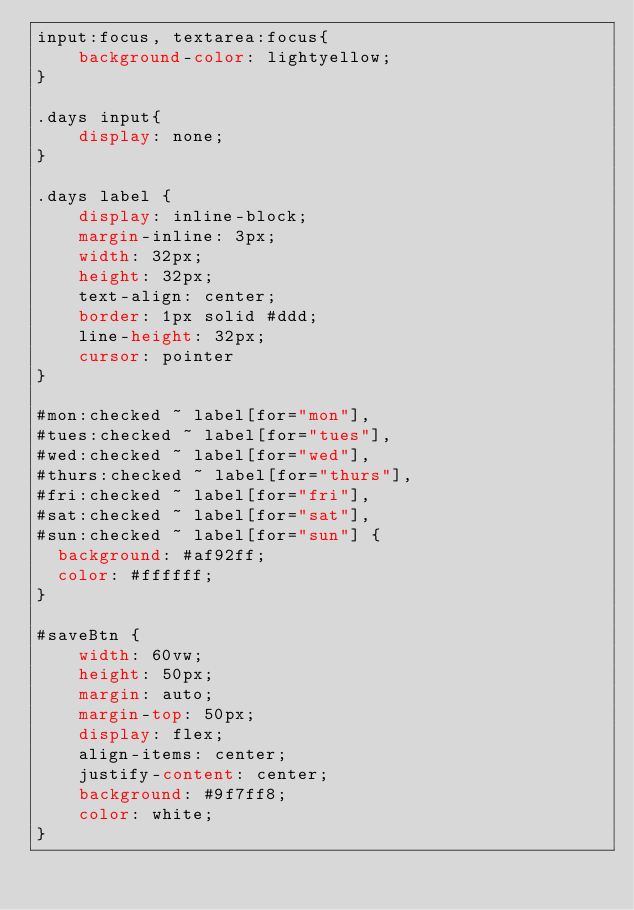<code> <loc_0><loc_0><loc_500><loc_500><_CSS_>input:focus, textarea:focus{
    background-color: lightyellow;
}

.days input{
    display: none;
}
  
.days label {
    display: inline-block;
    margin-inline: 3px;
    width: 32px;
    height: 32px;
    text-align: center;
    border: 1px solid #ddd;
    line-height: 32px;
    cursor: pointer
}

#mon:checked ~ label[for="mon"],
#tues:checked ~ label[for="tues"],
#wed:checked ~ label[for="wed"],
#thurs:checked ~ label[for="thurs"],
#fri:checked ~ label[for="fri"],
#sat:checked ~ label[for="sat"],
#sun:checked ~ label[for="sun"] {
  background: #af92ff;
  color: #ffffff;
}

#saveBtn {
    width: 60vw;
    height: 50px;
    margin: auto;
    margin-top: 50px;
    display: flex;
    align-items: center;
    justify-content: center;
    background: #9f7ff8;
    color: white;
}</code> 